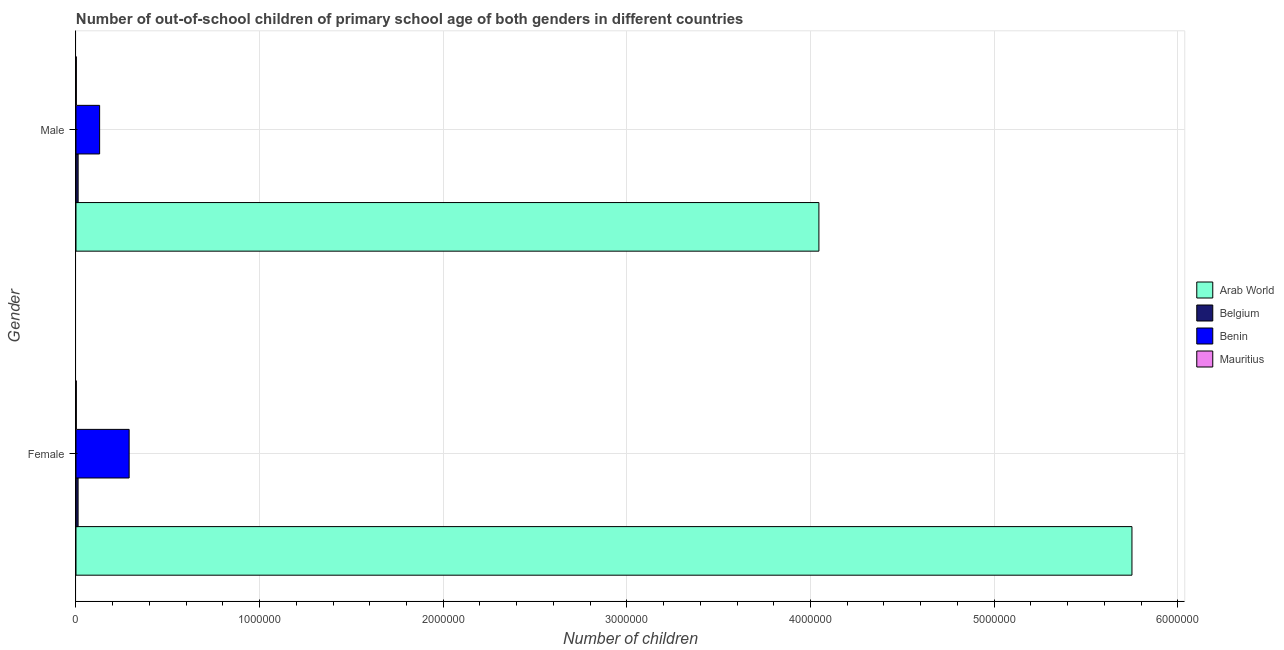How many different coloured bars are there?
Make the answer very short. 4. How many groups of bars are there?
Your answer should be very brief. 2. Are the number of bars on each tick of the Y-axis equal?
Your response must be concise. Yes. What is the label of the 2nd group of bars from the top?
Offer a very short reply. Female. What is the number of female out-of-school students in Belgium?
Your answer should be compact. 1.15e+04. Across all countries, what is the maximum number of male out-of-school students?
Offer a very short reply. 4.05e+06. Across all countries, what is the minimum number of female out-of-school students?
Provide a short and direct response. 1720. In which country was the number of male out-of-school students maximum?
Offer a very short reply. Arab World. In which country was the number of female out-of-school students minimum?
Give a very brief answer. Mauritius. What is the total number of male out-of-school students in the graph?
Ensure brevity in your answer.  4.19e+06. What is the difference between the number of female out-of-school students in Arab World and that in Mauritius?
Your answer should be very brief. 5.75e+06. What is the difference between the number of male out-of-school students in Benin and the number of female out-of-school students in Arab World?
Provide a succinct answer. -5.62e+06. What is the average number of male out-of-school students per country?
Keep it short and to the point. 1.05e+06. What is the difference between the number of female out-of-school students and number of male out-of-school students in Belgium?
Your answer should be very brief. -226. In how many countries, is the number of female out-of-school students greater than 1400000 ?
Give a very brief answer. 1. What is the ratio of the number of male out-of-school students in Benin to that in Arab World?
Your response must be concise. 0.03. Is the number of male out-of-school students in Mauritius less than that in Arab World?
Keep it short and to the point. Yes. What does the 3rd bar from the top in Male represents?
Offer a very short reply. Belgium. What does the 3rd bar from the bottom in Female represents?
Your answer should be compact. Benin. How many bars are there?
Provide a short and direct response. 8. Are all the bars in the graph horizontal?
Give a very brief answer. Yes. What is the difference between two consecutive major ticks on the X-axis?
Give a very brief answer. 1.00e+06. Does the graph contain any zero values?
Provide a succinct answer. No. How many legend labels are there?
Offer a terse response. 4. How are the legend labels stacked?
Your response must be concise. Vertical. What is the title of the graph?
Offer a very short reply. Number of out-of-school children of primary school age of both genders in different countries. Does "Korea (Republic)" appear as one of the legend labels in the graph?
Give a very brief answer. No. What is the label or title of the X-axis?
Give a very brief answer. Number of children. What is the label or title of the Y-axis?
Offer a terse response. Gender. What is the Number of children of Arab World in Female?
Keep it short and to the point. 5.75e+06. What is the Number of children of Belgium in Female?
Ensure brevity in your answer.  1.15e+04. What is the Number of children in Benin in Female?
Provide a succinct answer. 2.89e+05. What is the Number of children in Mauritius in Female?
Give a very brief answer. 1720. What is the Number of children in Arab World in Male?
Make the answer very short. 4.05e+06. What is the Number of children of Belgium in Male?
Keep it short and to the point. 1.17e+04. What is the Number of children in Benin in Male?
Make the answer very short. 1.29e+05. What is the Number of children in Mauritius in Male?
Offer a terse response. 1853. Across all Gender, what is the maximum Number of children in Arab World?
Your response must be concise. 5.75e+06. Across all Gender, what is the maximum Number of children in Belgium?
Make the answer very short. 1.17e+04. Across all Gender, what is the maximum Number of children of Benin?
Provide a short and direct response. 2.89e+05. Across all Gender, what is the maximum Number of children of Mauritius?
Your answer should be very brief. 1853. Across all Gender, what is the minimum Number of children in Arab World?
Give a very brief answer. 4.05e+06. Across all Gender, what is the minimum Number of children of Belgium?
Offer a very short reply. 1.15e+04. Across all Gender, what is the minimum Number of children in Benin?
Make the answer very short. 1.29e+05. Across all Gender, what is the minimum Number of children of Mauritius?
Offer a terse response. 1720. What is the total Number of children of Arab World in the graph?
Give a very brief answer. 9.80e+06. What is the total Number of children of Belgium in the graph?
Offer a terse response. 2.32e+04. What is the total Number of children of Benin in the graph?
Your answer should be very brief. 4.18e+05. What is the total Number of children in Mauritius in the graph?
Provide a succinct answer. 3573. What is the difference between the Number of children of Arab World in Female and that in Male?
Your response must be concise. 1.70e+06. What is the difference between the Number of children of Belgium in Female and that in Male?
Provide a succinct answer. -226. What is the difference between the Number of children of Benin in Female and that in Male?
Ensure brevity in your answer.  1.61e+05. What is the difference between the Number of children in Mauritius in Female and that in Male?
Keep it short and to the point. -133. What is the difference between the Number of children in Arab World in Female and the Number of children in Belgium in Male?
Ensure brevity in your answer.  5.74e+06. What is the difference between the Number of children in Arab World in Female and the Number of children in Benin in Male?
Your response must be concise. 5.62e+06. What is the difference between the Number of children of Arab World in Female and the Number of children of Mauritius in Male?
Provide a succinct answer. 5.75e+06. What is the difference between the Number of children in Belgium in Female and the Number of children in Benin in Male?
Offer a terse response. -1.17e+05. What is the difference between the Number of children in Belgium in Female and the Number of children in Mauritius in Male?
Ensure brevity in your answer.  9612. What is the difference between the Number of children in Benin in Female and the Number of children in Mauritius in Male?
Give a very brief answer. 2.88e+05. What is the average Number of children of Arab World per Gender?
Give a very brief answer. 4.90e+06. What is the average Number of children of Belgium per Gender?
Your answer should be compact. 1.16e+04. What is the average Number of children in Benin per Gender?
Your response must be concise. 2.09e+05. What is the average Number of children in Mauritius per Gender?
Provide a succinct answer. 1786.5. What is the difference between the Number of children in Arab World and Number of children in Belgium in Female?
Make the answer very short. 5.74e+06. What is the difference between the Number of children of Arab World and Number of children of Benin in Female?
Offer a terse response. 5.46e+06. What is the difference between the Number of children in Arab World and Number of children in Mauritius in Female?
Provide a succinct answer. 5.75e+06. What is the difference between the Number of children of Belgium and Number of children of Benin in Female?
Your answer should be compact. -2.78e+05. What is the difference between the Number of children of Belgium and Number of children of Mauritius in Female?
Keep it short and to the point. 9745. What is the difference between the Number of children in Benin and Number of children in Mauritius in Female?
Offer a very short reply. 2.88e+05. What is the difference between the Number of children of Arab World and Number of children of Belgium in Male?
Make the answer very short. 4.03e+06. What is the difference between the Number of children in Arab World and Number of children in Benin in Male?
Give a very brief answer. 3.92e+06. What is the difference between the Number of children in Arab World and Number of children in Mauritius in Male?
Your response must be concise. 4.04e+06. What is the difference between the Number of children in Belgium and Number of children in Benin in Male?
Your answer should be compact. -1.17e+05. What is the difference between the Number of children in Belgium and Number of children in Mauritius in Male?
Provide a succinct answer. 9838. What is the difference between the Number of children in Benin and Number of children in Mauritius in Male?
Ensure brevity in your answer.  1.27e+05. What is the ratio of the Number of children in Arab World in Female to that in Male?
Provide a short and direct response. 1.42. What is the ratio of the Number of children in Belgium in Female to that in Male?
Give a very brief answer. 0.98. What is the ratio of the Number of children of Benin in Female to that in Male?
Provide a short and direct response. 2.25. What is the ratio of the Number of children of Mauritius in Female to that in Male?
Give a very brief answer. 0.93. What is the difference between the highest and the second highest Number of children of Arab World?
Offer a terse response. 1.70e+06. What is the difference between the highest and the second highest Number of children of Belgium?
Give a very brief answer. 226. What is the difference between the highest and the second highest Number of children in Benin?
Offer a terse response. 1.61e+05. What is the difference between the highest and the second highest Number of children of Mauritius?
Ensure brevity in your answer.  133. What is the difference between the highest and the lowest Number of children in Arab World?
Your answer should be compact. 1.70e+06. What is the difference between the highest and the lowest Number of children in Belgium?
Your response must be concise. 226. What is the difference between the highest and the lowest Number of children in Benin?
Provide a succinct answer. 1.61e+05. What is the difference between the highest and the lowest Number of children in Mauritius?
Offer a very short reply. 133. 